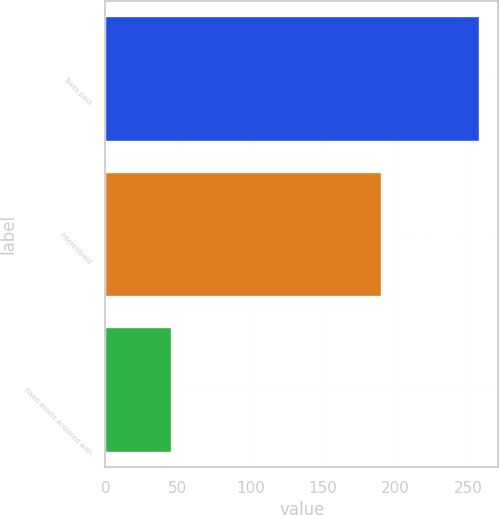Convert chart. <chart><loc_0><loc_0><loc_500><loc_500><bar_chart><fcel>Taxes paid<fcel>Interestpaid<fcel>Fixed assets acquired with<nl><fcel>258<fcel>190<fcel>45<nl></chart> 